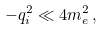Convert formula to latex. <formula><loc_0><loc_0><loc_500><loc_500>- q ^ { 2 } _ { i } \ll 4 m ^ { 2 } _ { e } \, ,</formula> 